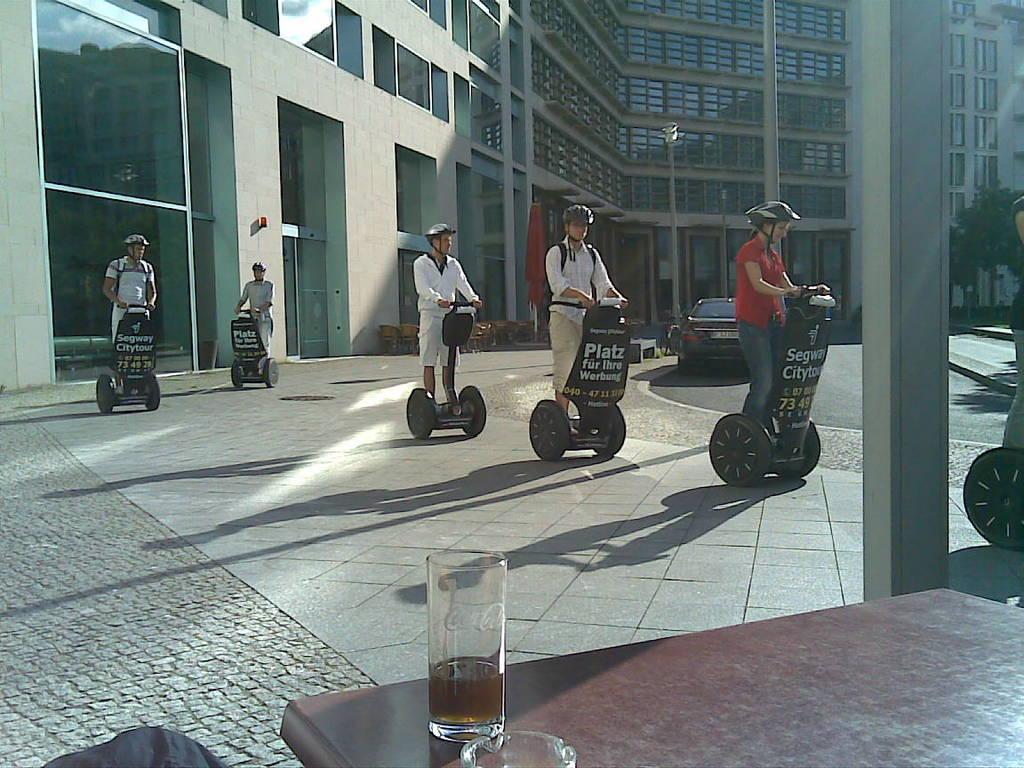In one or two sentences, can you explain what this image depicts? There are people riding hoverboards and wore helmets. We can see glasses on the table and pole. In the background we can see building, pole, chairs, flag and trees. 